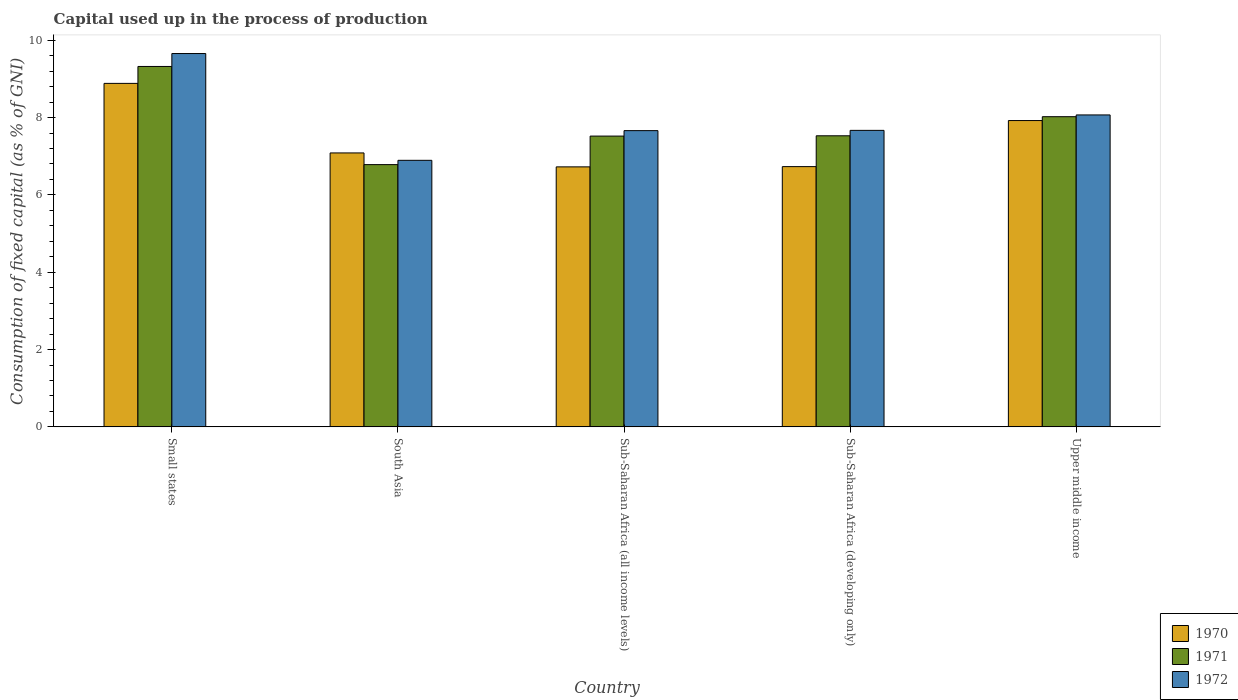How many different coloured bars are there?
Offer a terse response. 3. Are the number of bars per tick equal to the number of legend labels?
Make the answer very short. Yes. How many bars are there on the 2nd tick from the left?
Offer a very short reply. 3. What is the label of the 5th group of bars from the left?
Ensure brevity in your answer.  Upper middle income. In how many cases, is the number of bars for a given country not equal to the number of legend labels?
Offer a very short reply. 0. What is the capital used up in the process of production in 1971 in Upper middle income?
Offer a terse response. 8.02. Across all countries, what is the maximum capital used up in the process of production in 1970?
Give a very brief answer. 8.88. Across all countries, what is the minimum capital used up in the process of production in 1972?
Keep it short and to the point. 6.89. In which country was the capital used up in the process of production in 1971 maximum?
Make the answer very short. Small states. In which country was the capital used up in the process of production in 1971 minimum?
Offer a very short reply. South Asia. What is the total capital used up in the process of production in 1970 in the graph?
Provide a succinct answer. 37.35. What is the difference between the capital used up in the process of production in 1971 in Small states and that in Sub-Saharan Africa (developing only)?
Your answer should be very brief. 1.79. What is the difference between the capital used up in the process of production in 1972 in Upper middle income and the capital used up in the process of production in 1971 in South Asia?
Keep it short and to the point. 1.29. What is the average capital used up in the process of production in 1972 per country?
Offer a very short reply. 7.99. What is the difference between the capital used up in the process of production of/in 1971 and capital used up in the process of production of/in 1972 in Small states?
Keep it short and to the point. -0.33. What is the ratio of the capital used up in the process of production in 1971 in Small states to that in Sub-Saharan Africa (developing only)?
Make the answer very short. 1.24. Is the capital used up in the process of production in 1970 in Small states less than that in Upper middle income?
Offer a terse response. No. Is the difference between the capital used up in the process of production in 1971 in South Asia and Sub-Saharan Africa (all income levels) greater than the difference between the capital used up in the process of production in 1972 in South Asia and Sub-Saharan Africa (all income levels)?
Offer a very short reply. Yes. What is the difference between the highest and the second highest capital used up in the process of production in 1972?
Make the answer very short. -1.59. What is the difference between the highest and the lowest capital used up in the process of production in 1972?
Your answer should be very brief. 2.76. In how many countries, is the capital used up in the process of production in 1971 greater than the average capital used up in the process of production in 1971 taken over all countries?
Your answer should be very brief. 2. What does the 1st bar from the right in Upper middle income represents?
Ensure brevity in your answer.  1972. Are all the bars in the graph horizontal?
Give a very brief answer. No. What is the difference between two consecutive major ticks on the Y-axis?
Keep it short and to the point. 2. Are the values on the major ticks of Y-axis written in scientific E-notation?
Your answer should be very brief. No. Does the graph contain any zero values?
Keep it short and to the point. No. Where does the legend appear in the graph?
Provide a short and direct response. Bottom right. How are the legend labels stacked?
Your response must be concise. Vertical. What is the title of the graph?
Your response must be concise. Capital used up in the process of production. What is the label or title of the X-axis?
Ensure brevity in your answer.  Country. What is the label or title of the Y-axis?
Give a very brief answer. Consumption of fixed capital (as % of GNI). What is the Consumption of fixed capital (as % of GNI) in 1970 in Small states?
Provide a succinct answer. 8.88. What is the Consumption of fixed capital (as % of GNI) of 1971 in Small states?
Ensure brevity in your answer.  9.32. What is the Consumption of fixed capital (as % of GNI) of 1972 in Small states?
Provide a short and direct response. 9.66. What is the Consumption of fixed capital (as % of GNI) of 1970 in South Asia?
Ensure brevity in your answer.  7.09. What is the Consumption of fixed capital (as % of GNI) in 1971 in South Asia?
Offer a very short reply. 6.78. What is the Consumption of fixed capital (as % of GNI) of 1972 in South Asia?
Your answer should be compact. 6.89. What is the Consumption of fixed capital (as % of GNI) of 1970 in Sub-Saharan Africa (all income levels)?
Provide a short and direct response. 6.72. What is the Consumption of fixed capital (as % of GNI) of 1971 in Sub-Saharan Africa (all income levels)?
Provide a short and direct response. 7.52. What is the Consumption of fixed capital (as % of GNI) of 1972 in Sub-Saharan Africa (all income levels)?
Your answer should be compact. 7.66. What is the Consumption of fixed capital (as % of GNI) of 1970 in Sub-Saharan Africa (developing only)?
Offer a very short reply. 6.73. What is the Consumption of fixed capital (as % of GNI) in 1971 in Sub-Saharan Africa (developing only)?
Offer a very short reply. 7.53. What is the Consumption of fixed capital (as % of GNI) of 1972 in Sub-Saharan Africa (developing only)?
Your answer should be compact. 7.67. What is the Consumption of fixed capital (as % of GNI) of 1970 in Upper middle income?
Make the answer very short. 7.92. What is the Consumption of fixed capital (as % of GNI) in 1971 in Upper middle income?
Ensure brevity in your answer.  8.02. What is the Consumption of fixed capital (as % of GNI) of 1972 in Upper middle income?
Provide a short and direct response. 8.07. Across all countries, what is the maximum Consumption of fixed capital (as % of GNI) in 1970?
Your answer should be compact. 8.88. Across all countries, what is the maximum Consumption of fixed capital (as % of GNI) of 1971?
Your response must be concise. 9.32. Across all countries, what is the maximum Consumption of fixed capital (as % of GNI) of 1972?
Provide a short and direct response. 9.66. Across all countries, what is the minimum Consumption of fixed capital (as % of GNI) of 1970?
Keep it short and to the point. 6.72. Across all countries, what is the minimum Consumption of fixed capital (as % of GNI) of 1971?
Keep it short and to the point. 6.78. Across all countries, what is the minimum Consumption of fixed capital (as % of GNI) of 1972?
Keep it short and to the point. 6.89. What is the total Consumption of fixed capital (as % of GNI) in 1970 in the graph?
Your response must be concise. 37.35. What is the total Consumption of fixed capital (as % of GNI) of 1971 in the graph?
Your response must be concise. 39.18. What is the total Consumption of fixed capital (as % of GNI) in 1972 in the graph?
Your answer should be very brief. 39.95. What is the difference between the Consumption of fixed capital (as % of GNI) of 1970 in Small states and that in South Asia?
Offer a very short reply. 1.8. What is the difference between the Consumption of fixed capital (as % of GNI) in 1971 in Small states and that in South Asia?
Give a very brief answer. 2.54. What is the difference between the Consumption of fixed capital (as % of GNI) in 1972 in Small states and that in South Asia?
Your answer should be very brief. 2.76. What is the difference between the Consumption of fixed capital (as % of GNI) in 1970 in Small states and that in Sub-Saharan Africa (all income levels)?
Offer a very short reply. 2.16. What is the difference between the Consumption of fixed capital (as % of GNI) of 1971 in Small states and that in Sub-Saharan Africa (all income levels)?
Ensure brevity in your answer.  1.8. What is the difference between the Consumption of fixed capital (as % of GNI) in 1972 in Small states and that in Sub-Saharan Africa (all income levels)?
Offer a terse response. 1.99. What is the difference between the Consumption of fixed capital (as % of GNI) of 1970 in Small states and that in Sub-Saharan Africa (developing only)?
Keep it short and to the point. 2.15. What is the difference between the Consumption of fixed capital (as % of GNI) in 1971 in Small states and that in Sub-Saharan Africa (developing only)?
Your answer should be compact. 1.79. What is the difference between the Consumption of fixed capital (as % of GNI) in 1972 in Small states and that in Sub-Saharan Africa (developing only)?
Offer a terse response. 1.99. What is the difference between the Consumption of fixed capital (as % of GNI) of 1970 in Small states and that in Upper middle income?
Provide a short and direct response. 0.96. What is the difference between the Consumption of fixed capital (as % of GNI) in 1971 in Small states and that in Upper middle income?
Your answer should be very brief. 1.3. What is the difference between the Consumption of fixed capital (as % of GNI) in 1972 in Small states and that in Upper middle income?
Your answer should be compact. 1.59. What is the difference between the Consumption of fixed capital (as % of GNI) in 1970 in South Asia and that in Sub-Saharan Africa (all income levels)?
Keep it short and to the point. 0.36. What is the difference between the Consumption of fixed capital (as % of GNI) in 1971 in South Asia and that in Sub-Saharan Africa (all income levels)?
Your answer should be very brief. -0.74. What is the difference between the Consumption of fixed capital (as % of GNI) of 1972 in South Asia and that in Sub-Saharan Africa (all income levels)?
Your response must be concise. -0.77. What is the difference between the Consumption of fixed capital (as % of GNI) in 1970 in South Asia and that in Sub-Saharan Africa (developing only)?
Provide a succinct answer. 0.35. What is the difference between the Consumption of fixed capital (as % of GNI) in 1971 in South Asia and that in Sub-Saharan Africa (developing only)?
Make the answer very short. -0.75. What is the difference between the Consumption of fixed capital (as % of GNI) in 1972 in South Asia and that in Sub-Saharan Africa (developing only)?
Provide a succinct answer. -0.77. What is the difference between the Consumption of fixed capital (as % of GNI) in 1970 in South Asia and that in Upper middle income?
Ensure brevity in your answer.  -0.84. What is the difference between the Consumption of fixed capital (as % of GNI) of 1971 in South Asia and that in Upper middle income?
Offer a terse response. -1.24. What is the difference between the Consumption of fixed capital (as % of GNI) in 1972 in South Asia and that in Upper middle income?
Ensure brevity in your answer.  -1.17. What is the difference between the Consumption of fixed capital (as % of GNI) of 1970 in Sub-Saharan Africa (all income levels) and that in Sub-Saharan Africa (developing only)?
Make the answer very short. -0.01. What is the difference between the Consumption of fixed capital (as % of GNI) of 1971 in Sub-Saharan Africa (all income levels) and that in Sub-Saharan Africa (developing only)?
Offer a very short reply. -0.01. What is the difference between the Consumption of fixed capital (as % of GNI) in 1972 in Sub-Saharan Africa (all income levels) and that in Sub-Saharan Africa (developing only)?
Ensure brevity in your answer.  -0.01. What is the difference between the Consumption of fixed capital (as % of GNI) of 1970 in Sub-Saharan Africa (all income levels) and that in Upper middle income?
Give a very brief answer. -1.2. What is the difference between the Consumption of fixed capital (as % of GNI) in 1971 in Sub-Saharan Africa (all income levels) and that in Upper middle income?
Offer a very short reply. -0.5. What is the difference between the Consumption of fixed capital (as % of GNI) in 1972 in Sub-Saharan Africa (all income levels) and that in Upper middle income?
Your answer should be very brief. -0.41. What is the difference between the Consumption of fixed capital (as % of GNI) of 1970 in Sub-Saharan Africa (developing only) and that in Upper middle income?
Keep it short and to the point. -1.19. What is the difference between the Consumption of fixed capital (as % of GNI) of 1971 in Sub-Saharan Africa (developing only) and that in Upper middle income?
Your answer should be compact. -0.49. What is the difference between the Consumption of fixed capital (as % of GNI) in 1972 in Sub-Saharan Africa (developing only) and that in Upper middle income?
Keep it short and to the point. -0.4. What is the difference between the Consumption of fixed capital (as % of GNI) in 1970 in Small states and the Consumption of fixed capital (as % of GNI) in 1971 in South Asia?
Make the answer very short. 2.1. What is the difference between the Consumption of fixed capital (as % of GNI) of 1970 in Small states and the Consumption of fixed capital (as % of GNI) of 1972 in South Asia?
Your answer should be compact. 1.99. What is the difference between the Consumption of fixed capital (as % of GNI) in 1971 in Small states and the Consumption of fixed capital (as % of GNI) in 1972 in South Asia?
Offer a very short reply. 2.43. What is the difference between the Consumption of fixed capital (as % of GNI) in 1970 in Small states and the Consumption of fixed capital (as % of GNI) in 1971 in Sub-Saharan Africa (all income levels)?
Give a very brief answer. 1.36. What is the difference between the Consumption of fixed capital (as % of GNI) in 1970 in Small states and the Consumption of fixed capital (as % of GNI) in 1972 in Sub-Saharan Africa (all income levels)?
Offer a very short reply. 1.22. What is the difference between the Consumption of fixed capital (as % of GNI) of 1971 in Small states and the Consumption of fixed capital (as % of GNI) of 1972 in Sub-Saharan Africa (all income levels)?
Provide a short and direct response. 1.66. What is the difference between the Consumption of fixed capital (as % of GNI) in 1970 in Small states and the Consumption of fixed capital (as % of GNI) in 1971 in Sub-Saharan Africa (developing only)?
Make the answer very short. 1.36. What is the difference between the Consumption of fixed capital (as % of GNI) in 1970 in Small states and the Consumption of fixed capital (as % of GNI) in 1972 in Sub-Saharan Africa (developing only)?
Provide a short and direct response. 1.22. What is the difference between the Consumption of fixed capital (as % of GNI) of 1971 in Small states and the Consumption of fixed capital (as % of GNI) of 1972 in Sub-Saharan Africa (developing only)?
Ensure brevity in your answer.  1.65. What is the difference between the Consumption of fixed capital (as % of GNI) in 1970 in Small states and the Consumption of fixed capital (as % of GNI) in 1971 in Upper middle income?
Offer a terse response. 0.86. What is the difference between the Consumption of fixed capital (as % of GNI) of 1970 in Small states and the Consumption of fixed capital (as % of GNI) of 1972 in Upper middle income?
Provide a succinct answer. 0.82. What is the difference between the Consumption of fixed capital (as % of GNI) in 1971 in Small states and the Consumption of fixed capital (as % of GNI) in 1972 in Upper middle income?
Your answer should be compact. 1.25. What is the difference between the Consumption of fixed capital (as % of GNI) in 1970 in South Asia and the Consumption of fixed capital (as % of GNI) in 1971 in Sub-Saharan Africa (all income levels)?
Make the answer very short. -0.44. What is the difference between the Consumption of fixed capital (as % of GNI) in 1970 in South Asia and the Consumption of fixed capital (as % of GNI) in 1972 in Sub-Saharan Africa (all income levels)?
Offer a terse response. -0.58. What is the difference between the Consumption of fixed capital (as % of GNI) in 1971 in South Asia and the Consumption of fixed capital (as % of GNI) in 1972 in Sub-Saharan Africa (all income levels)?
Your answer should be very brief. -0.88. What is the difference between the Consumption of fixed capital (as % of GNI) in 1970 in South Asia and the Consumption of fixed capital (as % of GNI) in 1971 in Sub-Saharan Africa (developing only)?
Your response must be concise. -0.44. What is the difference between the Consumption of fixed capital (as % of GNI) of 1970 in South Asia and the Consumption of fixed capital (as % of GNI) of 1972 in Sub-Saharan Africa (developing only)?
Provide a short and direct response. -0.58. What is the difference between the Consumption of fixed capital (as % of GNI) of 1971 in South Asia and the Consumption of fixed capital (as % of GNI) of 1972 in Sub-Saharan Africa (developing only)?
Your response must be concise. -0.89. What is the difference between the Consumption of fixed capital (as % of GNI) in 1970 in South Asia and the Consumption of fixed capital (as % of GNI) in 1971 in Upper middle income?
Your response must be concise. -0.94. What is the difference between the Consumption of fixed capital (as % of GNI) of 1970 in South Asia and the Consumption of fixed capital (as % of GNI) of 1972 in Upper middle income?
Provide a short and direct response. -0.98. What is the difference between the Consumption of fixed capital (as % of GNI) of 1971 in South Asia and the Consumption of fixed capital (as % of GNI) of 1972 in Upper middle income?
Keep it short and to the point. -1.28. What is the difference between the Consumption of fixed capital (as % of GNI) in 1970 in Sub-Saharan Africa (all income levels) and the Consumption of fixed capital (as % of GNI) in 1971 in Sub-Saharan Africa (developing only)?
Give a very brief answer. -0.8. What is the difference between the Consumption of fixed capital (as % of GNI) of 1970 in Sub-Saharan Africa (all income levels) and the Consumption of fixed capital (as % of GNI) of 1972 in Sub-Saharan Africa (developing only)?
Provide a short and direct response. -0.94. What is the difference between the Consumption of fixed capital (as % of GNI) of 1971 in Sub-Saharan Africa (all income levels) and the Consumption of fixed capital (as % of GNI) of 1972 in Sub-Saharan Africa (developing only)?
Offer a very short reply. -0.15. What is the difference between the Consumption of fixed capital (as % of GNI) of 1970 in Sub-Saharan Africa (all income levels) and the Consumption of fixed capital (as % of GNI) of 1971 in Upper middle income?
Your response must be concise. -1.3. What is the difference between the Consumption of fixed capital (as % of GNI) in 1970 in Sub-Saharan Africa (all income levels) and the Consumption of fixed capital (as % of GNI) in 1972 in Upper middle income?
Make the answer very short. -1.34. What is the difference between the Consumption of fixed capital (as % of GNI) of 1971 in Sub-Saharan Africa (all income levels) and the Consumption of fixed capital (as % of GNI) of 1972 in Upper middle income?
Give a very brief answer. -0.55. What is the difference between the Consumption of fixed capital (as % of GNI) in 1970 in Sub-Saharan Africa (developing only) and the Consumption of fixed capital (as % of GNI) in 1971 in Upper middle income?
Make the answer very short. -1.29. What is the difference between the Consumption of fixed capital (as % of GNI) in 1970 in Sub-Saharan Africa (developing only) and the Consumption of fixed capital (as % of GNI) in 1972 in Upper middle income?
Provide a succinct answer. -1.34. What is the difference between the Consumption of fixed capital (as % of GNI) of 1971 in Sub-Saharan Africa (developing only) and the Consumption of fixed capital (as % of GNI) of 1972 in Upper middle income?
Your answer should be compact. -0.54. What is the average Consumption of fixed capital (as % of GNI) in 1970 per country?
Offer a terse response. 7.47. What is the average Consumption of fixed capital (as % of GNI) in 1971 per country?
Give a very brief answer. 7.84. What is the average Consumption of fixed capital (as % of GNI) in 1972 per country?
Offer a terse response. 7.99. What is the difference between the Consumption of fixed capital (as % of GNI) in 1970 and Consumption of fixed capital (as % of GNI) in 1971 in Small states?
Provide a succinct answer. -0.44. What is the difference between the Consumption of fixed capital (as % of GNI) of 1970 and Consumption of fixed capital (as % of GNI) of 1972 in Small states?
Offer a very short reply. -0.77. What is the difference between the Consumption of fixed capital (as % of GNI) of 1971 and Consumption of fixed capital (as % of GNI) of 1972 in Small states?
Ensure brevity in your answer.  -0.33. What is the difference between the Consumption of fixed capital (as % of GNI) in 1970 and Consumption of fixed capital (as % of GNI) in 1971 in South Asia?
Your response must be concise. 0.3. What is the difference between the Consumption of fixed capital (as % of GNI) in 1970 and Consumption of fixed capital (as % of GNI) in 1972 in South Asia?
Your response must be concise. 0.19. What is the difference between the Consumption of fixed capital (as % of GNI) in 1971 and Consumption of fixed capital (as % of GNI) in 1972 in South Asia?
Ensure brevity in your answer.  -0.11. What is the difference between the Consumption of fixed capital (as % of GNI) of 1970 and Consumption of fixed capital (as % of GNI) of 1971 in Sub-Saharan Africa (all income levels)?
Your response must be concise. -0.8. What is the difference between the Consumption of fixed capital (as % of GNI) in 1970 and Consumption of fixed capital (as % of GNI) in 1972 in Sub-Saharan Africa (all income levels)?
Your response must be concise. -0.94. What is the difference between the Consumption of fixed capital (as % of GNI) of 1971 and Consumption of fixed capital (as % of GNI) of 1972 in Sub-Saharan Africa (all income levels)?
Offer a very short reply. -0.14. What is the difference between the Consumption of fixed capital (as % of GNI) in 1970 and Consumption of fixed capital (as % of GNI) in 1971 in Sub-Saharan Africa (developing only)?
Your answer should be compact. -0.8. What is the difference between the Consumption of fixed capital (as % of GNI) in 1970 and Consumption of fixed capital (as % of GNI) in 1972 in Sub-Saharan Africa (developing only)?
Give a very brief answer. -0.94. What is the difference between the Consumption of fixed capital (as % of GNI) in 1971 and Consumption of fixed capital (as % of GNI) in 1972 in Sub-Saharan Africa (developing only)?
Your answer should be compact. -0.14. What is the difference between the Consumption of fixed capital (as % of GNI) in 1970 and Consumption of fixed capital (as % of GNI) in 1971 in Upper middle income?
Your answer should be compact. -0.1. What is the difference between the Consumption of fixed capital (as % of GNI) of 1970 and Consumption of fixed capital (as % of GNI) of 1972 in Upper middle income?
Make the answer very short. -0.15. What is the difference between the Consumption of fixed capital (as % of GNI) of 1971 and Consumption of fixed capital (as % of GNI) of 1972 in Upper middle income?
Your answer should be compact. -0.05. What is the ratio of the Consumption of fixed capital (as % of GNI) of 1970 in Small states to that in South Asia?
Give a very brief answer. 1.25. What is the ratio of the Consumption of fixed capital (as % of GNI) of 1971 in Small states to that in South Asia?
Ensure brevity in your answer.  1.37. What is the ratio of the Consumption of fixed capital (as % of GNI) in 1972 in Small states to that in South Asia?
Your answer should be very brief. 1.4. What is the ratio of the Consumption of fixed capital (as % of GNI) of 1970 in Small states to that in Sub-Saharan Africa (all income levels)?
Provide a short and direct response. 1.32. What is the ratio of the Consumption of fixed capital (as % of GNI) of 1971 in Small states to that in Sub-Saharan Africa (all income levels)?
Provide a short and direct response. 1.24. What is the ratio of the Consumption of fixed capital (as % of GNI) of 1972 in Small states to that in Sub-Saharan Africa (all income levels)?
Your response must be concise. 1.26. What is the ratio of the Consumption of fixed capital (as % of GNI) in 1970 in Small states to that in Sub-Saharan Africa (developing only)?
Give a very brief answer. 1.32. What is the ratio of the Consumption of fixed capital (as % of GNI) of 1971 in Small states to that in Sub-Saharan Africa (developing only)?
Ensure brevity in your answer.  1.24. What is the ratio of the Consumption of fixed capital (as % of GNI) of 1972 in Small states to that in Sub-Saharan Africa (developing only)?
Provide a short and direct response. 1.26. What is the ratio of the Consumption of fixed capital (as % of GNI) of 1970 in Small states to that in Upper middle income?
Make the answer very short. 1.12. What is the ratio of the Consumption of fixed capital (as % of GNI) of 1971 in Small states to that in Upper middle income?
Your response must be concise. 1.16. What is the ratio of the Consumption of fixed capital (as % of GNI) of 1972 in Small states to that in Upper middle income?
Ensure brevity in your answer.  1.2. What is the ratio of the Consumption of fixed capital (as % of GNI) of 1970 in South Asia to that in Sub-Saharan Africa (all income levels)?
Provide a succinct answer. 1.05. What is the ratio of the Consumption of fixed capital (as % of GNI) in 1971 in South Asia to that in Sub-Saharan Africa (all income levels)?
Provide a short and direct response. 0.9. What is the ratio of the Consumption of fixed capital (as % of GNI) of 1972 in South Asia to that in Sub-Saharan Africa (all income levels)?
Make the answer very short. 0.9. What is the ratio of the Consumption of fixed capital (as % of GNI) in 1970 in South Asia to that in Sub-Saharan Africa (developing only)?
Ensure brevity in your answer.  1.05. What is the ratio of the Consumption of fixed capital (as % of GNI) of 1971 in South Asia to that in Sub-Saharan Africa (developing only)?
Make the answer very short. 0.9. What is the ratio of the Consumption of fixed capital (as % of GNI) in 1972 in South Asia to that in Sub-Saharan Africa (developing only)?
Offer a very short reply. 0.9. What is the ratio of the Consumption of fixed capital (as % of GNI) of 1970 in South Asia to that in Upper middle income?
Give a very brief answer. 0.89. What is the ratio of the Consumption of fixed capital (as % of GNI) in 1971 in South Asia to that in Upper middle income?
Give a very brief answer. 0.85. What is the ratio of the Consumption of fixed capital (as % of GNI) in 1972 in South Asia to that in Upper middle income?
Offer a terse response. 0.85. What is the ratio of the Consumption of fixed capital (as % of GNI) of 1971 in Sub-Saharan Africa (all income levels) to that in Sub-Saharan Africa (developing only)?
Your response must be concise. 1. What is the ratio of the Consumption of fixed capital (as % of GNI) of 1970 in Sub-Saharan Africa (all income levels) to that in Upper middle income?
Offer a terse response. 0.85. What is the ratio of the Consumption of fixed capital (as % of GNI) in 1971 in Sub-Saharan Africa (all income levels) to that in Upper middle income?
Provide a succinct answer. 0.94. What is the ratio of the Consumption of fixed capital (as % of GNI) in 1972 in Sub-Saharan Africa (all income levels) to that in Upper middle income?
Ensure brevity in your answer.  0.95. What is the ratio of the Consumption of fixed capital (as % of GNI) in 1970 in Sub-Saharan Africa (developing only) to that in Upper middle income?
Give a very brief answer. 0.85. What is the ratio of the Consumption of fixed capital (as % of GNI) of 1971 in Sub-Saharan Africa (developing only) to that in Upper middle income?
Keep it short and to the point. 0.94. What is the ratio of the Consumption of fixed capital (as % of GNI) of 1972 in Sub-Saharan Africa (developing only) to that in Upper middle income?
Offer a very short reply. 0.95. What is the difference between the highest and the second highest Consumption of fixed capital (as % of GNI) of 1970?
Ensure brevity in your answer.  0.96. What is the difference between the highest and the second highest Consumption of fixed capital (as % of GNI) of 1971?
Provide a short and direct response. 1.3. What is the difference between the highest and the second highest Consumption of fixed capital (as % of GNI) of 1972?
Your answer should be compact. 1.59. What is the difference between the highest and the lowest Consumption of fixed capital (as % of GNI) in 1970?
Your answer should be very brief. 2.16. What is the difference between the highest and the lowest Consumption of fixed capital (as % of GNI) in 1971?
Your answer should be very brief. 2.54. What is the difference between the highest and the lowest Consumption of fixed capital (as % of GNI) of 1972?
Make the answer very short. 2.76. 